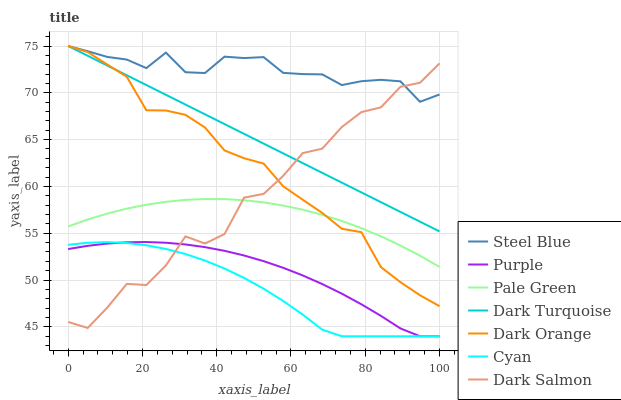Does Purple have the minimum area under the curve?
Answer yes or no. No. Does Purple have the maximum area under the curve?
Answer yes or no. No. Is Purple the smoothest?
Answer yes or no. No. Is Purple the roughest?
Answer yes or no. No. Does Dark Turquoise have the lowest value?
Answer yes or no. No. Does Purple have the highest value?
Answer yes or no. No. Is Purple less than Pale Green?
Answer yes or no. Yes. Is Dark Turquoise greater than Pale Green?
Answer yes or no. Yes. Does Purple intersect Pale Green?
Answer yes or no. No. 